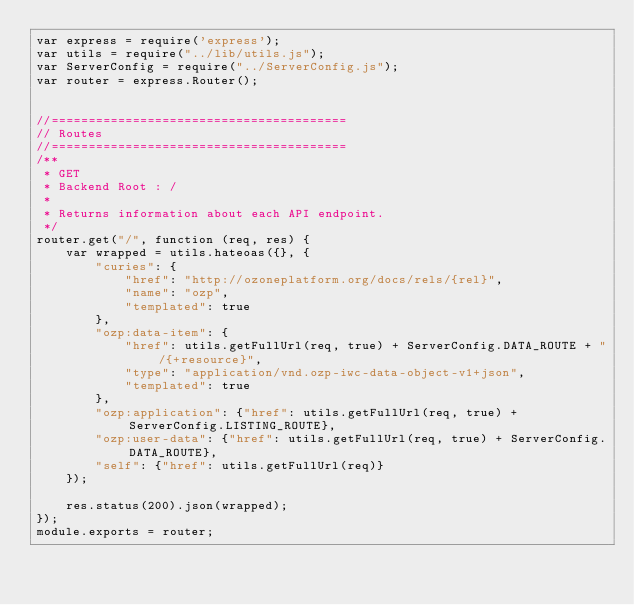<code> <loc_0><loc_0><loc_500><loc_500><_JavaScript_>var express = require('express');
var utils = require("../lib/utils.js");
var ServerConfig = require("../ServerConfig.js");
var router = express.Router();


//========================================
// Routes
//========================================
/**
 * GET
 * Backend Root : /
 *
 * Returns information about each API endpoint.
 */
router.get("/", function (req, res) {
    var wrapped = utils.hateoas({}, {
        "curies": {
            "href": "http://ozoneplatform.org/docs/rels/{rel}",
            "name": "ozp",
            "templated": true
        },
        "ozp:data-item": {
            "href": utils.getFullUrl(req, true) + ServerConfig.DATA_ROUTE + "/{+resource}",
            "type": "application/vnd.ozp-iwc-data-object-v1+json",
            "templated": true
        },
        "ozp:application": {"href": utils.getFullUrl(req, true) + ServerConfig.LISTING_ROUTE},
        "ozp:user-data": {"href": utils.getFullUrl(req, true) + ServerConfig.DATA_ROUTE},
        "self": {"href": utils.getFullUrl(req)}
    });

    res.status(200).json(wrapped);
});
module.exports = router;
</code> 